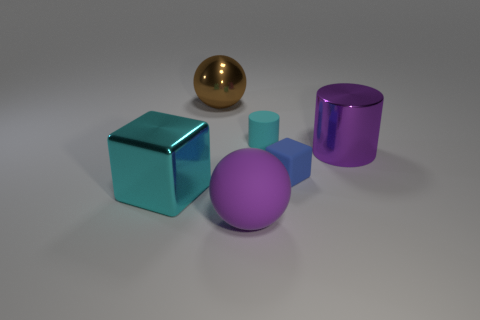Add 1 big purple metal cylinders. How many objects exist? 7 Subtract all big purple cylinders. Subtract all cyan metal blocks. How many objects are left? 4 Add 4 large metallic cylinders. How many large metallic cylinders are left? 5 Add 1 tiny purple blocks. How many tiny purple blocks exist? 1 Subtract 0 red cylinders. How many objects are left? 6 Subtract all blocks. How many objects are left? 4 